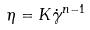<formula> <loc_0><loc_0><loc_500><loc_500>\eta = K \dot { \gamma } ^ { n - 1 }</formula> 